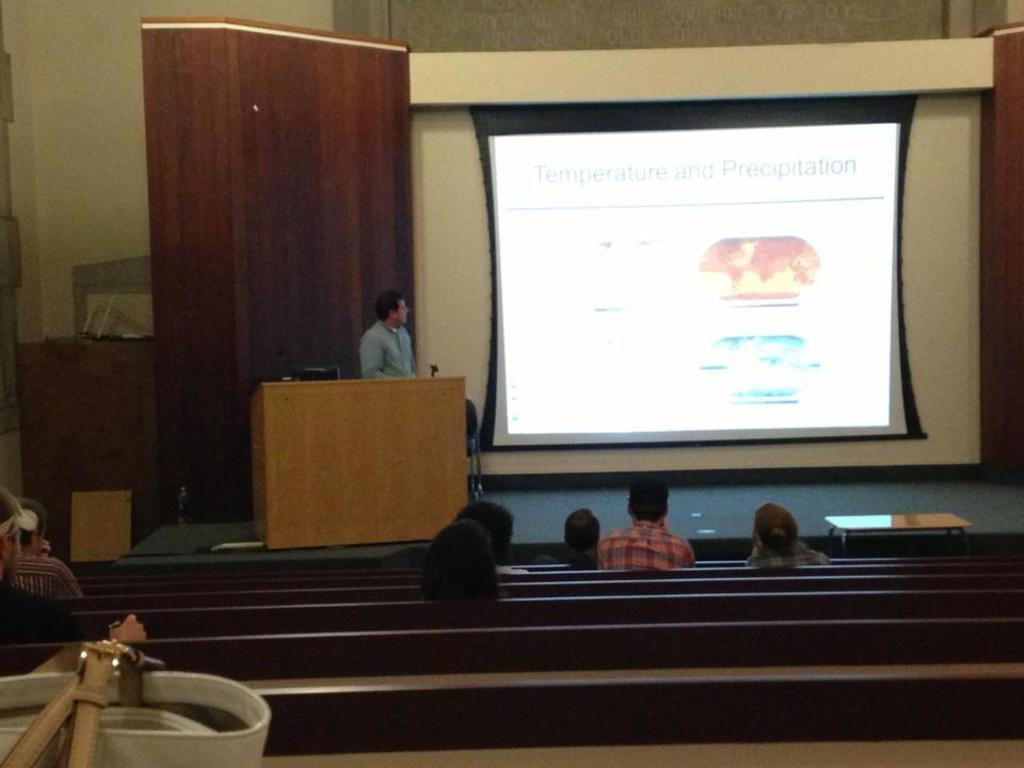Can you describe this image briefly? Few persons are sitting and we can see bag, benches and table. This man standing,in front of this man we can see laptop on table and we can see screen and wall. 